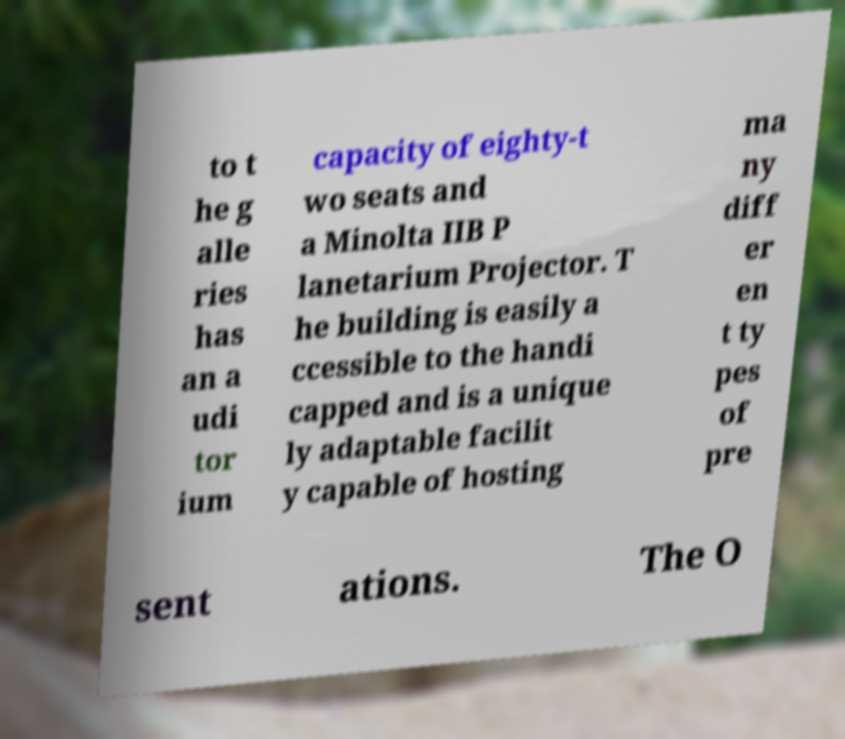What messages or text are displayed in this image? I need them in a readable, typed format. to t he g alle ries has an a udi tor ium capacity of eighty-t wo seats and a Minolta IIB P lanetarium Projector. T he building is easily a ccessible to the handi capped and is a unique ly adaptable facilit y capable of hosting ma ny diff er en t ty pes of pre sent ations. The O 